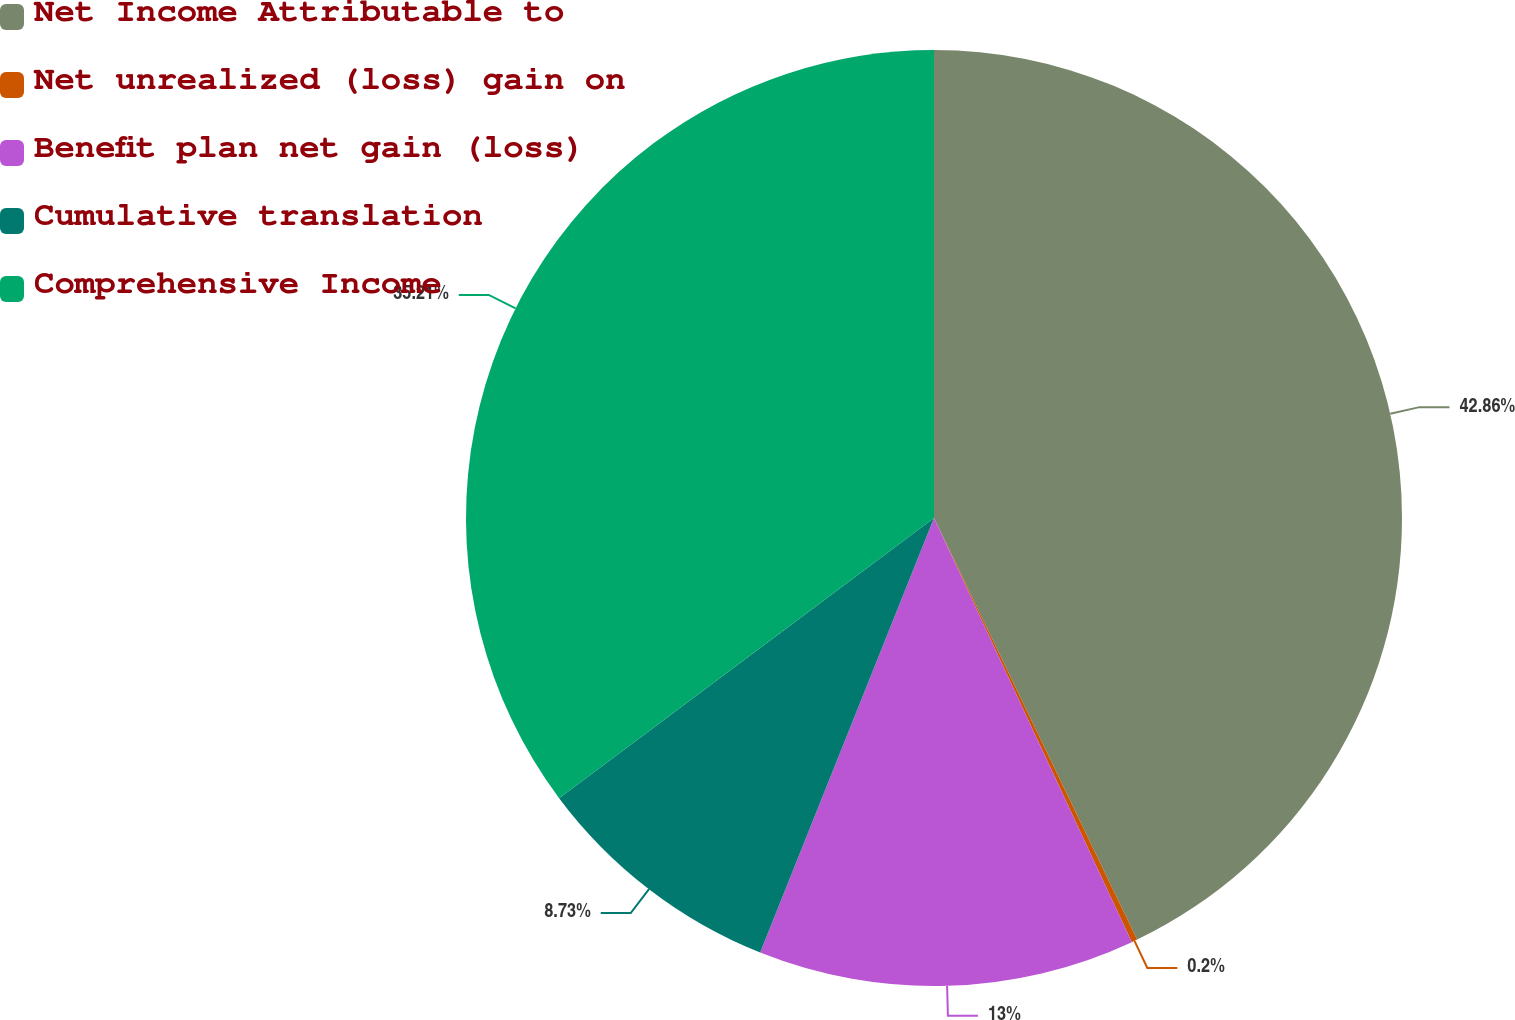<chart> <loc_0><loc_0><loc_500><loc_500><pie_chart><fcel>Net Income Attributable to<fcel>Net unrealized (loss) gain on<fcel>Benefit plan net gain (loss)<fcel>Cumulative translation<fcel>Comprehensive Income<nl><fcel>42.85%<fcel>0.2%<fcel>13.0%<fcel>8.73%<fcel>35.21%<nl></chart> 